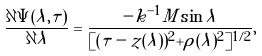Convert formula to latex. <formula><loc_0><loc_0><loc_500><loc_500>\frac { \partial \Psi ( \lambda , \tau ) } { \partial \lambda } = \frac { - k ^ { - 1 } M \sin \lambda } { [ ( \tau - z ( \lambda ) ) ^ { 2 } + \rho ( \lambda ) ^ { 2 } ] ^ { 1 / 2 } } ,</formula> 